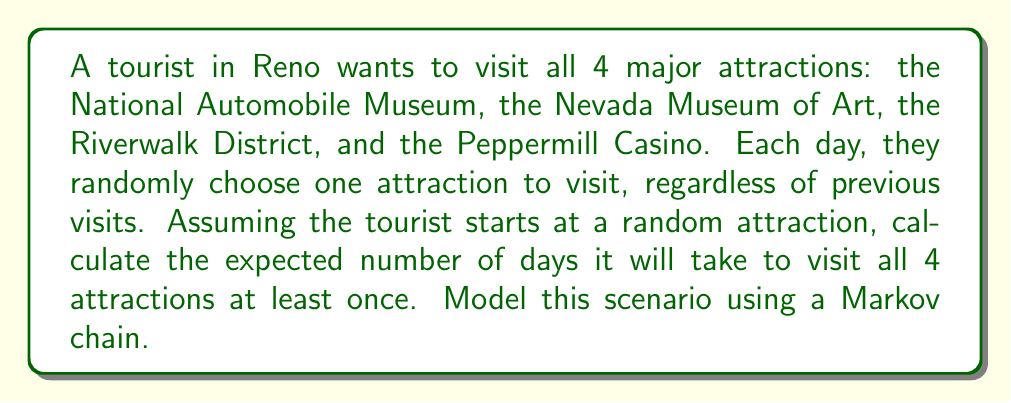Solve this math problem. Let's approach this step-by-step using a Markov chain model:

1) First, we need to define our states. Let's represent them as:
   0: No new attractions visited
   1: 1 new attraction visited
   2: 2 new attractions visited
   3: 3 new attractions visited
   4: All 4 attractions visited (absorbing state)

2) Now, let's calculate the transition probabilities:
   
   From state 0: P(0→1) = 1
   From state 1: P(1→1) = 1/4, P(1→2) = 3/4
   From state 2: P(2→2) = 2/4 = 1/2, P(2→3) = 2/4 = 1/2
   From state 3: P(3→3) = 3/4, P(3→4) = 1/4
   State 4 is absorbing: P(4→4) = 1

3) We can represent this as a transition matrix P:

   $$P = \begin{bmatrix}
   0 & 1 & 0 & 0 & 0 \\
   0 & 1/4 & 3/4 & 0 & 0 \\
   0 & 0 & 1/2 & 1/2 & 0 \\
   0 & 0 & 0 & 3/4 & 1/4 \\
   0 & 0 & 0 & 0 & 1
   \end{bmatrix}$$

4) To find the expected number of steps to absorption, we need to calculate:
   $$E[T] = (I - Q)^{-1} \mathbf{1}$$
   where Q is the submatrix of P without the absorbing state, I is the identity matrix, and $\mathbf{1}$ is a column vector of ones.

5) Q matrix:
   $$Q = \begin{bmatrix}
   0 & 1 & 0 & 0 \\
   0 & 1/4 & 3/4 & 0 \\
   0 & 0 & 1/2 & 1/2 \\
   0 & 0 & 0 & 3/4
   \end{bmatrix}$$

6) Calculate I - Q:
   $$I - Q = \begin{bmatrix}
   1 & -1 & 0 & 0 \\
   0 & 3/4 & -3/4 & 0 \\
   0 & 0 & 1/2 & -1/2 \\
   0 & 0 & 0 & 1/4
   \end{bmatrix}$$

7) Calculate $(I - Q)^{-1}$:
   $$(I - Q)^{-1} = \begin{bmatrix}
   1 & 4/3 & 2 & 8 \\
   0 & 4/3 & 2 & 8 \\
   0 & 0 & 2 & 8 \\
   0 & 0 & 0 & 4
   \end{bmatrix}$$

8) Multiply by $\mathbf{1}$ and sum the results:
   $$E[T] = 1 + 4/3 + 2 + 8 = 12.33$$

Therefore, the expected number of days to visit all attractions is approximately 12.33 days.
Answer: 12.33 days 